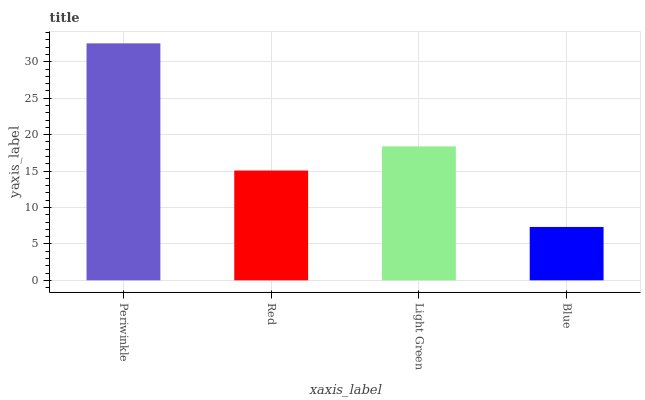Is Red the minimum?
Answer yes or no. No. Is Red the maximum?
Answer yes or no. No. Is Periwinkle greater than Red?
Answer yes or no. Yes. Is Red less than Periwinkle?
Answer yes or no. Yes. Is Red greater than Periwinkle?
Answer yes or no. No. Is Periwinkle less than Red?
Answer yes or no. No. Is Light Green the high median?
Answer yes or no. Yes. Is Red the low median?
Answer yes or no. Yes. Is Red the high median?
Answer yes or no. No. Is Light Green the low median?
Answer yes or no. No. 